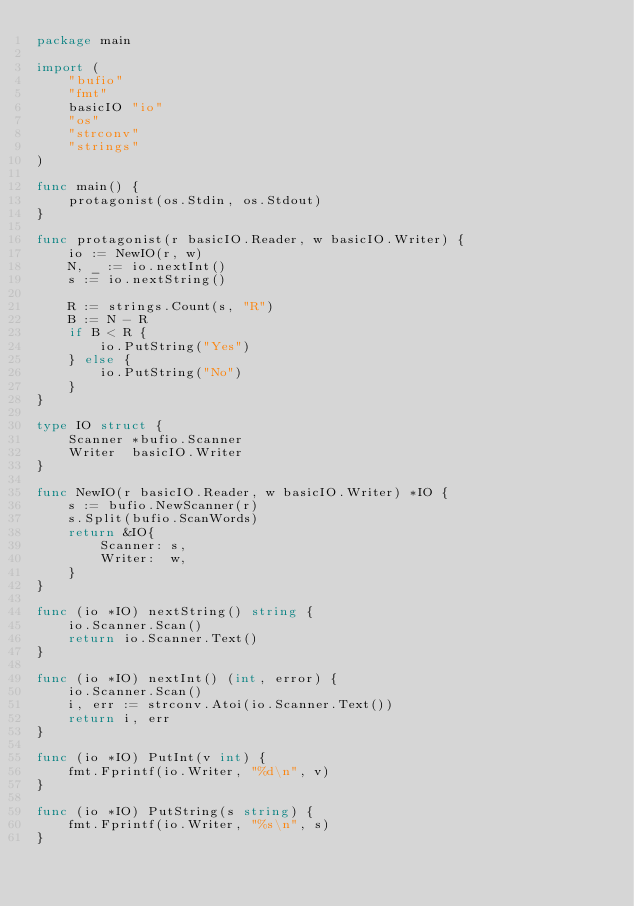Convert code to text. <code><loc_0><loc_0><loc_500><loc_500><_Go_>package main

import (
	"bufio"
	"fmt"
	basicIO "io"
	"os"
	"strconv"
	"strings"
)

func main() {
	protagonist(os.Stdin, os.Stdout)
}

func protagonist(r basicIO.Reader, w basicIO.Writer) {
	io := NewIO(r, w)
	N, _ := io.nextInt()
	s := io.nextString()

	R := strings.Count(s, "R")
	B := N - R
	if B < R {
		io.PutString("Yes")
	} else {
		io.PutString("No")
	}
}

type IO struct {
	Scanner *bufio.Scanner
	Writer  basicIO.Writer
}

func NewIO(r basicIO.Reader, w basicIO.Writer) *IO {
	s := bufio.NewScanner(r)
	s.Split(bufio.ScanWords)
	return &IO{
		Scanner: s,
		Writer:  w,
	}
}

func (io *IO) nextString() string {
	io.Scanner.Scan()
	return io.Scanner.Text()
}

func (io *IO) nextInt() (int, error) {
	io.Scanner.Scan()
	i, err := strconv.Atoi(io.Scanner.Text())
	return i, err
}

func (io *IO) PutInt(v int) {
	fmt.Fprintf(io.Writer, "%d\n", v)
}

func (io *IO) PutString(s string) {
	fmt.Fprintf(io.Writer, "%s\n", s)
}
</code> 